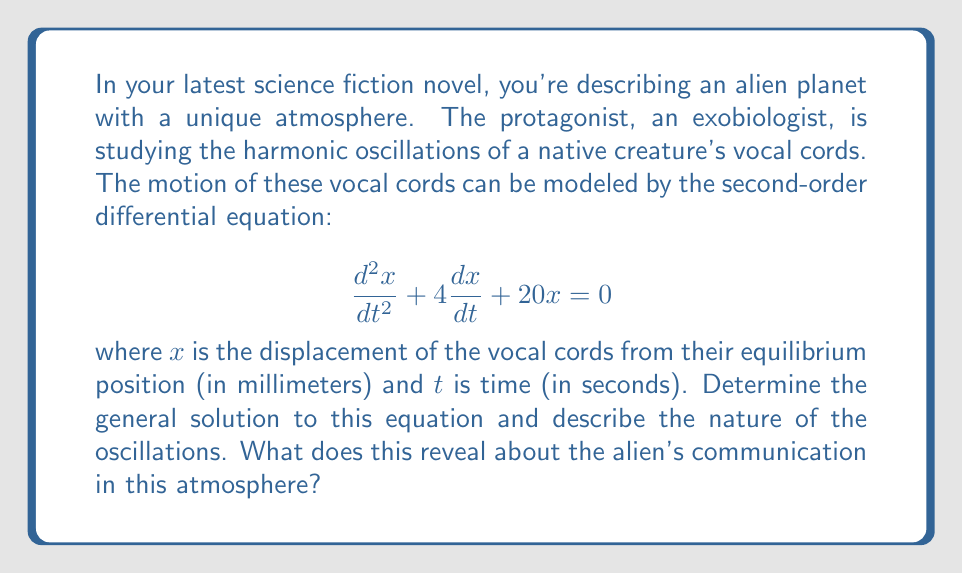Provide a solution to this math problem. To solve this second-order linear differential equation, we follow these steps:

1) First, we identify the characteristic equation:
   $$r^2 + 4r + 20 = 0$$

2) We solve this quadratic equation using the quadratic formula:
   $$r = \frac{-b \pm \sqrt{b^2 - 4ac}}{2a}$$
   $$r = \frac{-4 \pm \sqrt{4^2 - 4(1)(20)}}{2(1)}$$
   $$r = \frac{-4 \pm \sqrt{16 - 80}}{2} = \frac{-4 \pm \sqrt{-64}}{2} = \frac{-4 \pm 8i}{2}$$

3) This gives us two complex roots:
   $$r_1 = -2 + 4i$$ and $$r_2 = -2 - 4i$$

4) The general solution for complex roots is:
   $$x(t) = e^{at}(C_1 \cos(bt) + C_2 \sin(bt))$$
   where $a$ is the real part and $b$ is the imaginary part of the roots.

5) In this case, $a = -2$ and $b = 4$, so our general solution is:
   $$x(t) = e^{-2t}(C_1 \cos(4t) + C_2 \sin(4t))$$

This solution represents a damped harmonic oscillation. The $e^{-2t}$ term causes the amplitude to decrease over time, while the cosine and sine terms create the oscillatory behavior.

The oscillations have a natural frequency of 4 radians per second, and the damping factor of -2 indicates that the oscillations will decay relatively quickly.

For the alien's communication, this implies that their vocalizations would have a distinctive pitch (related to the frequency) but would quickly fade out. This could suggest a form of communication based on short, precise bursts of sound rather than sustained vocalizations.
Answer: The general solution is:
$$x(t) = e^{-2t}(C_1 \cos(4t) + C_2 \sin(4t))$$
where $C_1$ and $C_2$ are arbitrary constants determined by initial conditions. This represents a damped harmonic oscillation with a natural frequency of 4 rad/s and a damping factor of -2. 